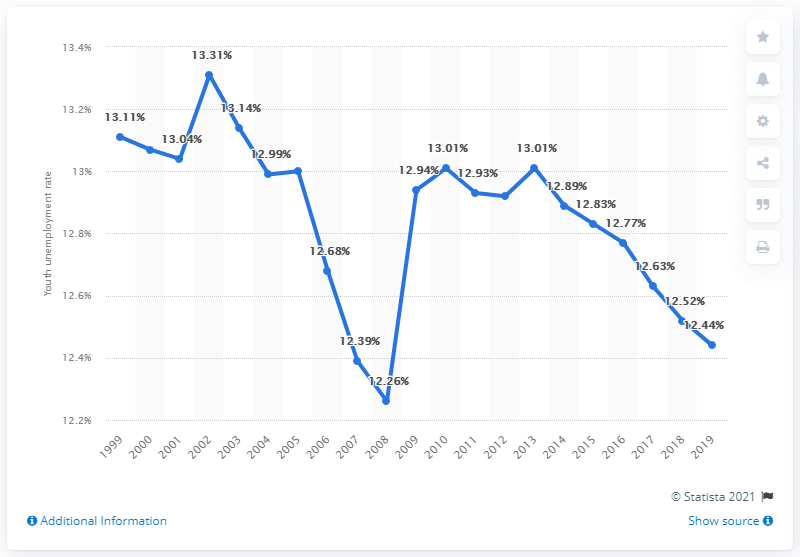What was the youth unemployment rate in the Gambia in 2019? In 2019, the youth unemployment rate in the Gambia was recorded at 12.44%. This figure represents a notable context in the fluctuating economic conditions affecting younger demographics within the country over the years, as seen in historical data trends. 